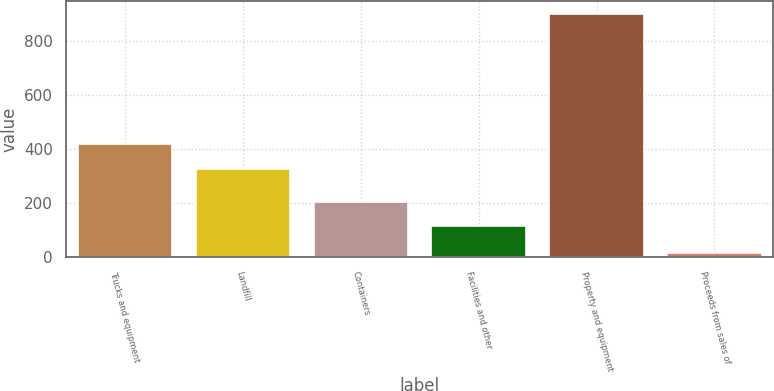<chart> <loc_0><loc_0><loc_500><loc_500><bar_chart><fcel>Trucks and equipment<fcel>Landfill<fcel>Containers<fcel>Facilities and other<fcel>Property and equipment<fcel>Proceeds from sales of<nl><fcel>417<fcel>327<fcel>204<fcel>114<fcel>900<fcel>15<nl></chart> 